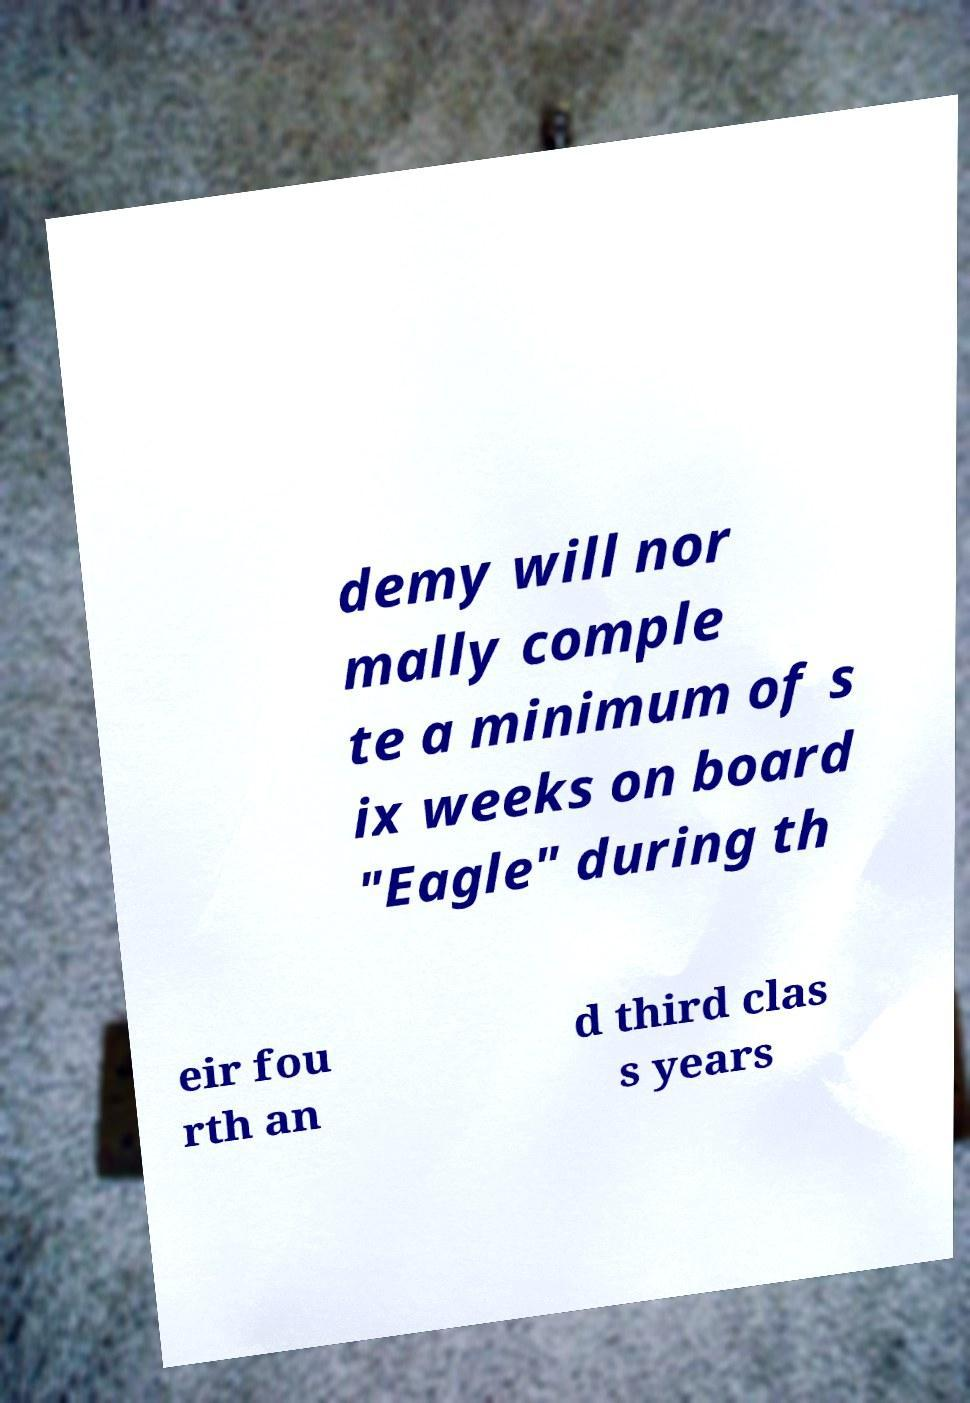I need the written content from this picture converted into text. Can you do that? demy will nor mally comple te a minimum of s ix weeks on board "Eagle" during th eir fou rth an d third clas s years 